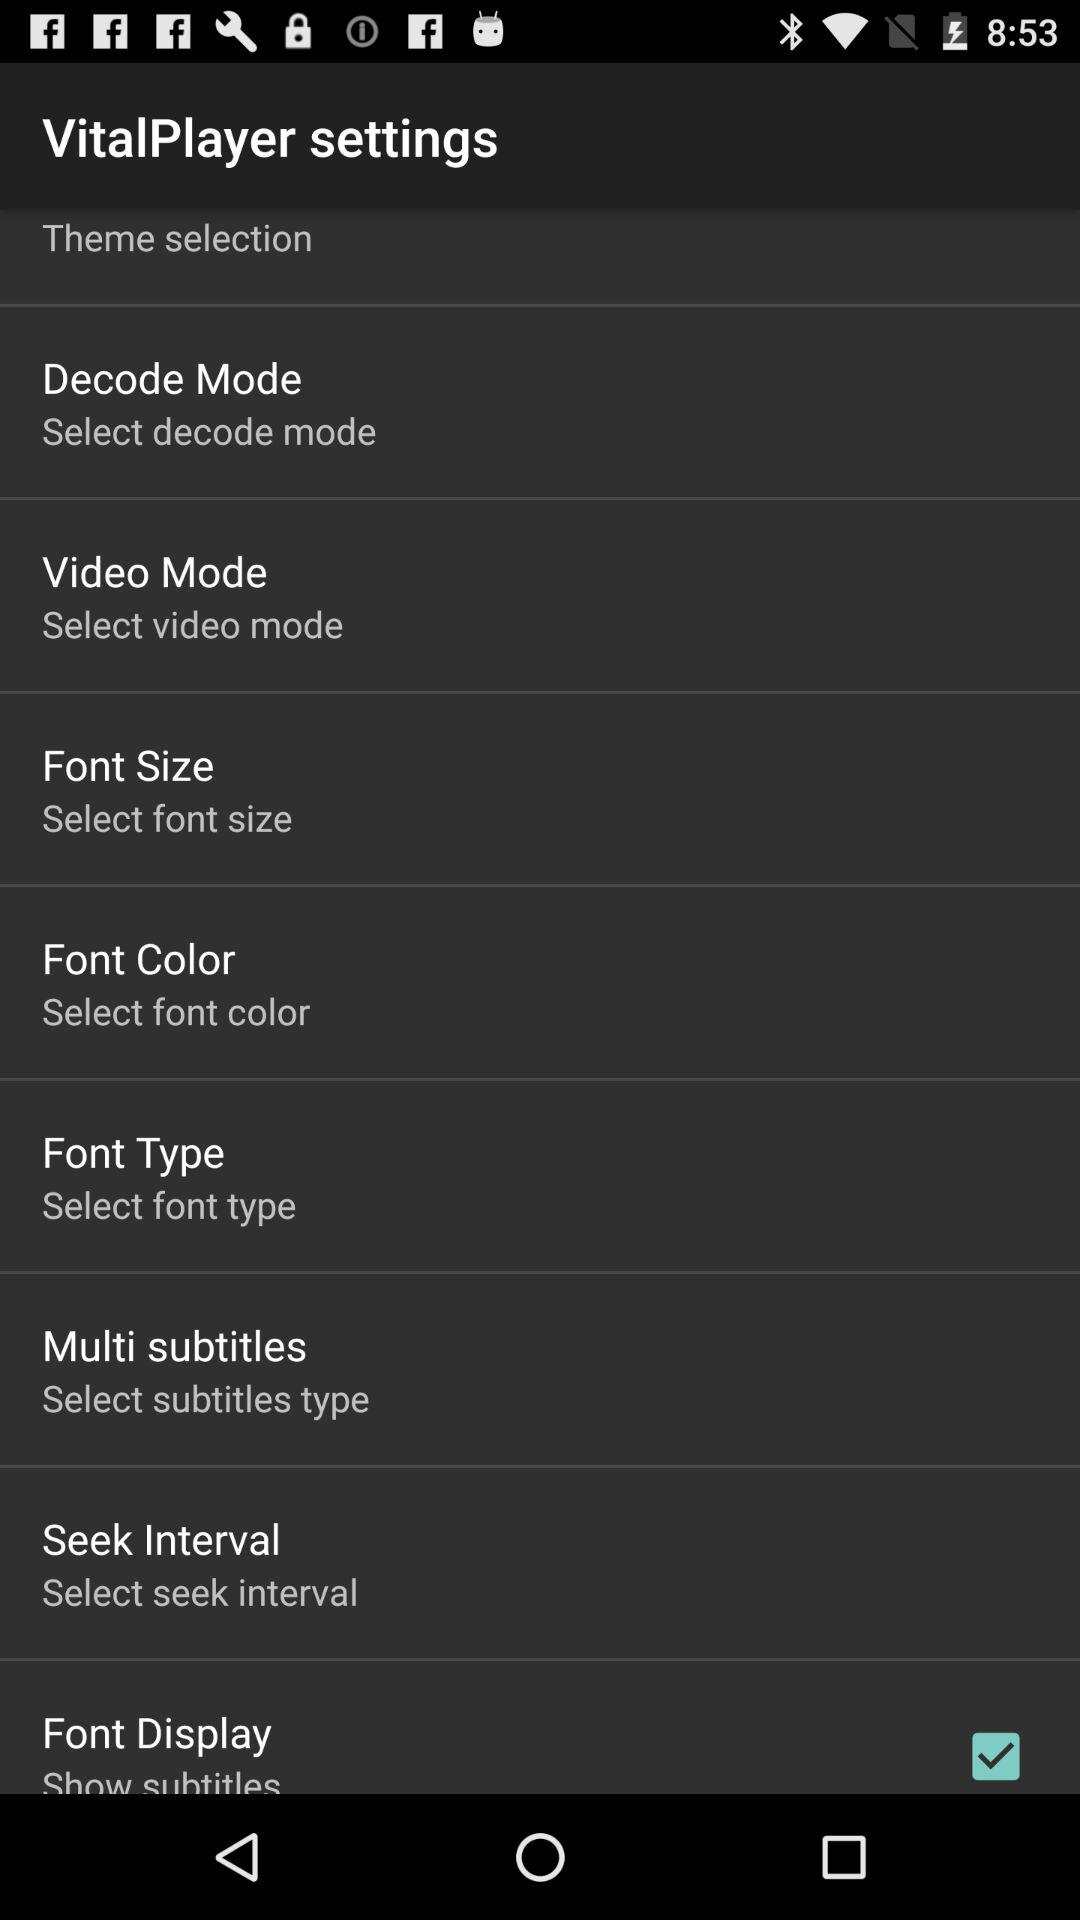What is the status of the "Font Display" setting? The status of the "Font Display" is "on". 